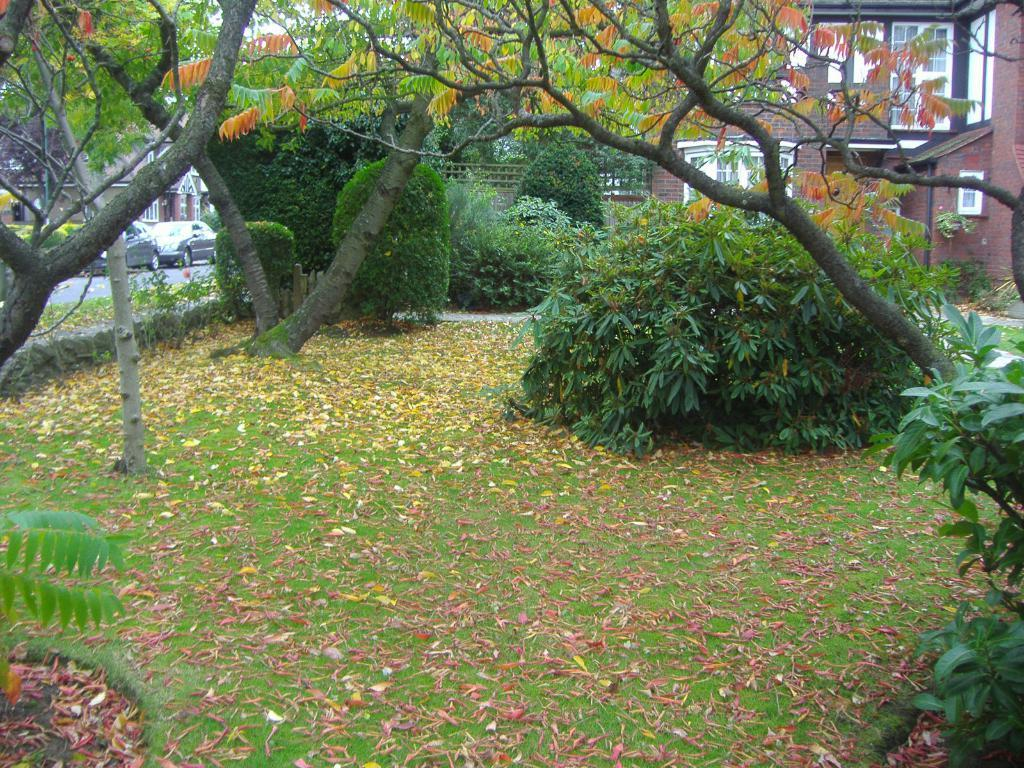What type of vegetation can be seen in the image? There are trees and bushes in the image. What is on the ground in the image? There are dried leaves on the ground. What can be seen in the background of the image? There are buildings with windows in the background. What else is present in the image besides vegetation and buildings? There are vehicles in the image. What title is given to the person talking in the image? There is no person talking in the image, as it only features trees, bushes, dried leaves, buildings, and vehicles. Is there any smoke visible in the image? There is no smoke present in the image. 